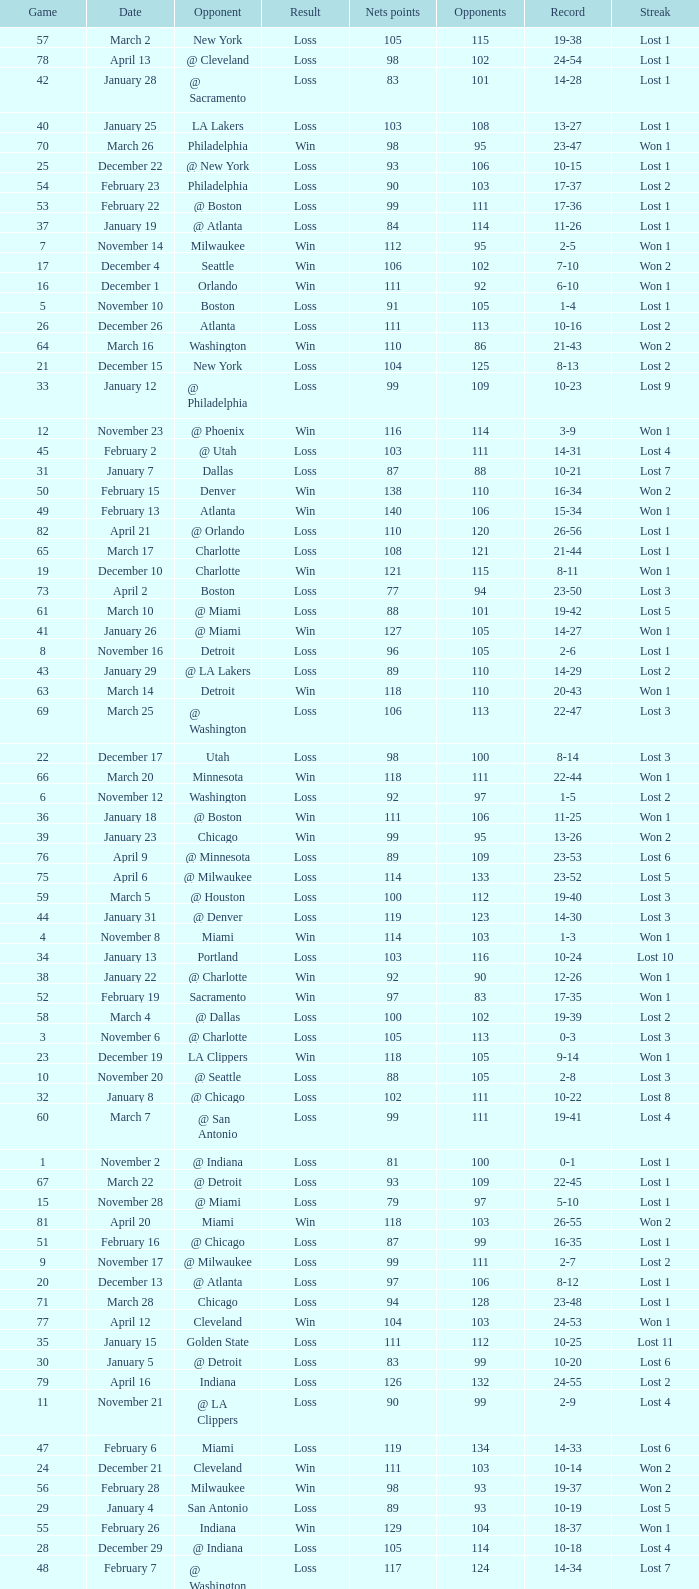In which game did the opponent score more than 103 and the record was 1-3? None. 